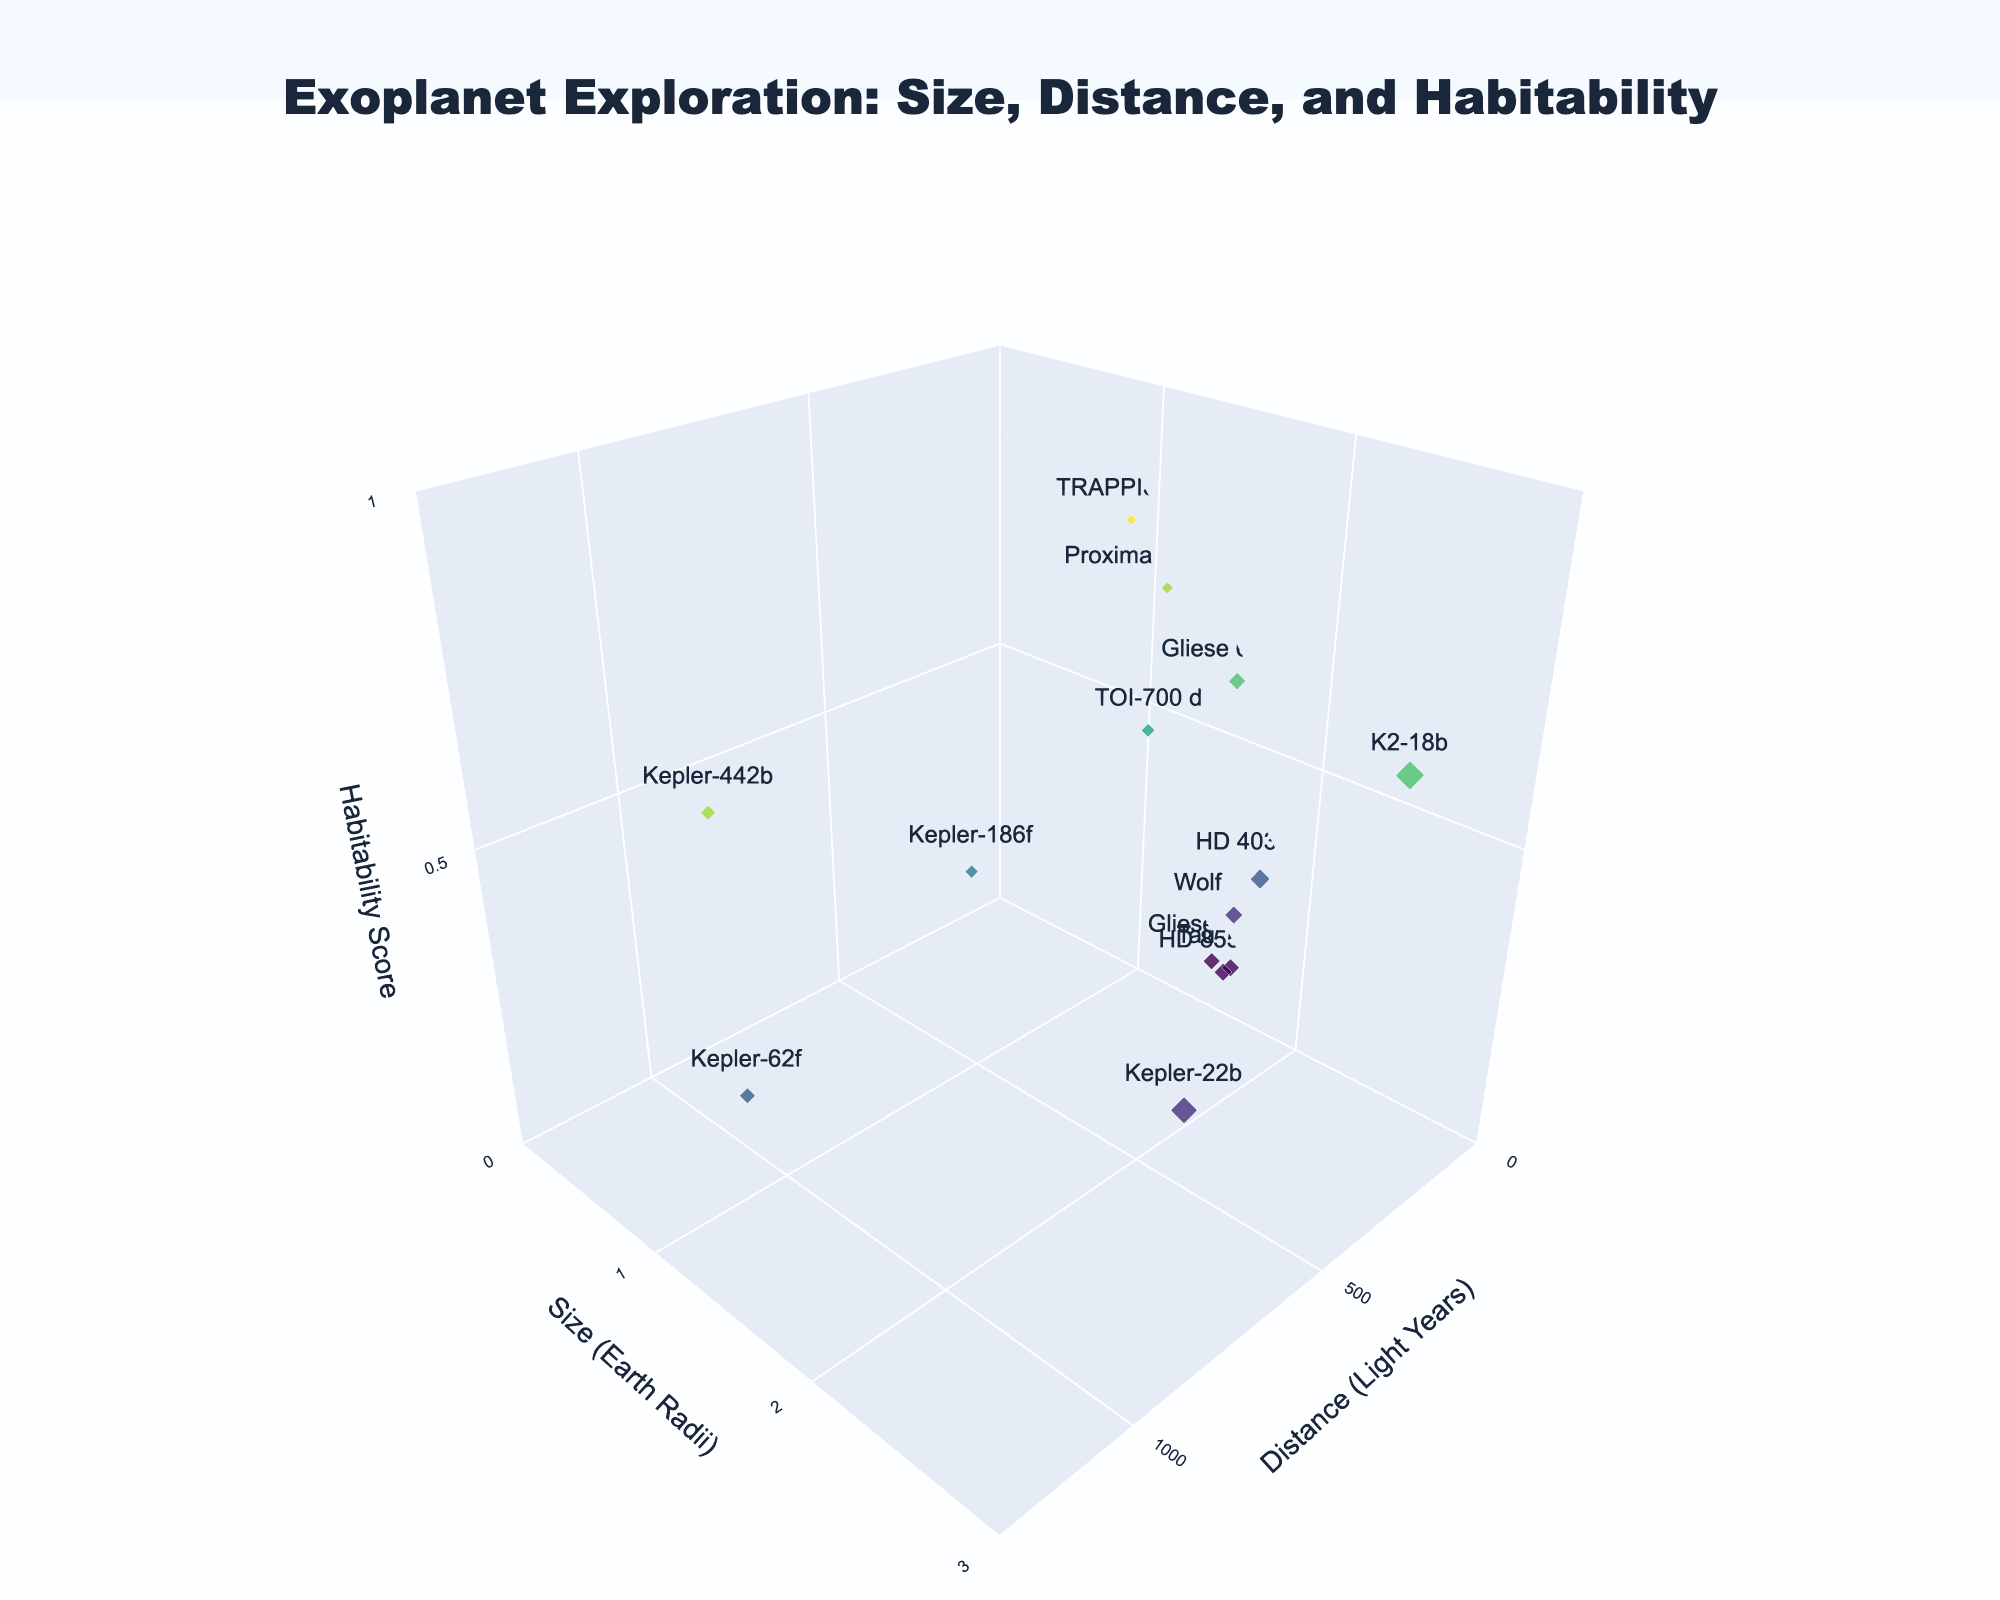What's the size (in Earth Radii) of TRAPPIST-1e? Locate TRAPPIST-1e in the plot and read the corresponding "Size (Earth Radii)" value on the y-axis.
Answer: 0.92 What is the range of the Habitability Scores for the planets shown? Observe the z-axis, which represents Habitability Scores, and identify the minimum and maximum values represented by the markers.
Answer: 0.1 to 0.8 Which exoplanet is the farthest from Earth? Identify the planet that is plotted at the maximum x-axis value representing distance in light years.
Answer: Kepler-442b Between Kepler-186f and Kepler-22b, which has a higher Habitability Score? Compare the z-axis (Habitability Score) values of Kepler-186f and Kepler-22b.
Answer: Kepler-186f What is the average size (in Earth Radii) of the exoplanets with a Habitability Score of 0.6? Identify the planets with a Habitability Score of 0.6 (K2-18b and Gliese 667 Cc), sum their sizes (2.6 and 1.54) and divide by the number of planets (2).
Answer: 2.07 How many planets are closer to Earth than 100 light years but have a Habitability Score less than 0.5? Count the planets within the x-axis range < 100 light years and z-axis (Habitability Score) < 0.5.
Answer: 2 (Tau Ceti e, HD 85512 b) Which exoplanet is largest in size? Identify the planet with the highest value on the y-axis representing size in Earth Radii.
Answer: K2-18b Compare the distances of Gliese 581g and Wolf 1061c from Earth. Which is closer? Locate both planets on the x-axis (Distance in Light Years) and compare their positions.
Answer: Tau Ceti e What is the total number of exoplanets plotted? Count the total number of data points/markers in the plot representing the exoplanets.
Answer: 13 Which planet has the highest Habitability Score and how far is it from Earth? Identify the planet with the maximum value on the z-axis (Habitability Score) and note its x-axis (Distance in Light Years) value.
Answer: TRAPPIST-1e, 39.6 light years 